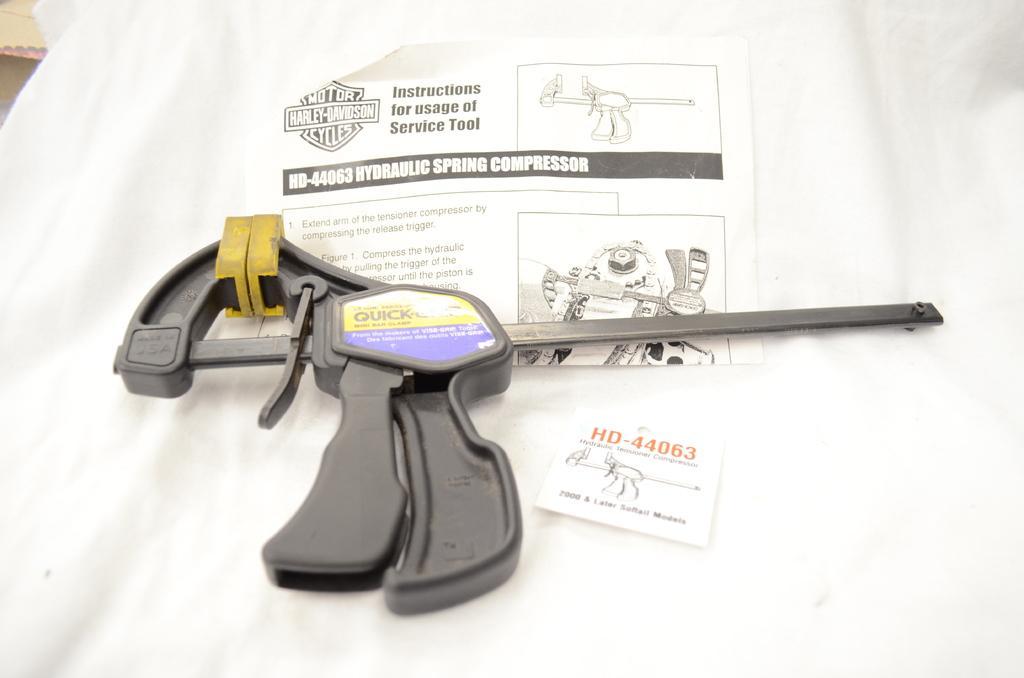Can you describe this image briefly? In this image we can see, there is a hydraulic spring compressor and stickers on the white cover. 